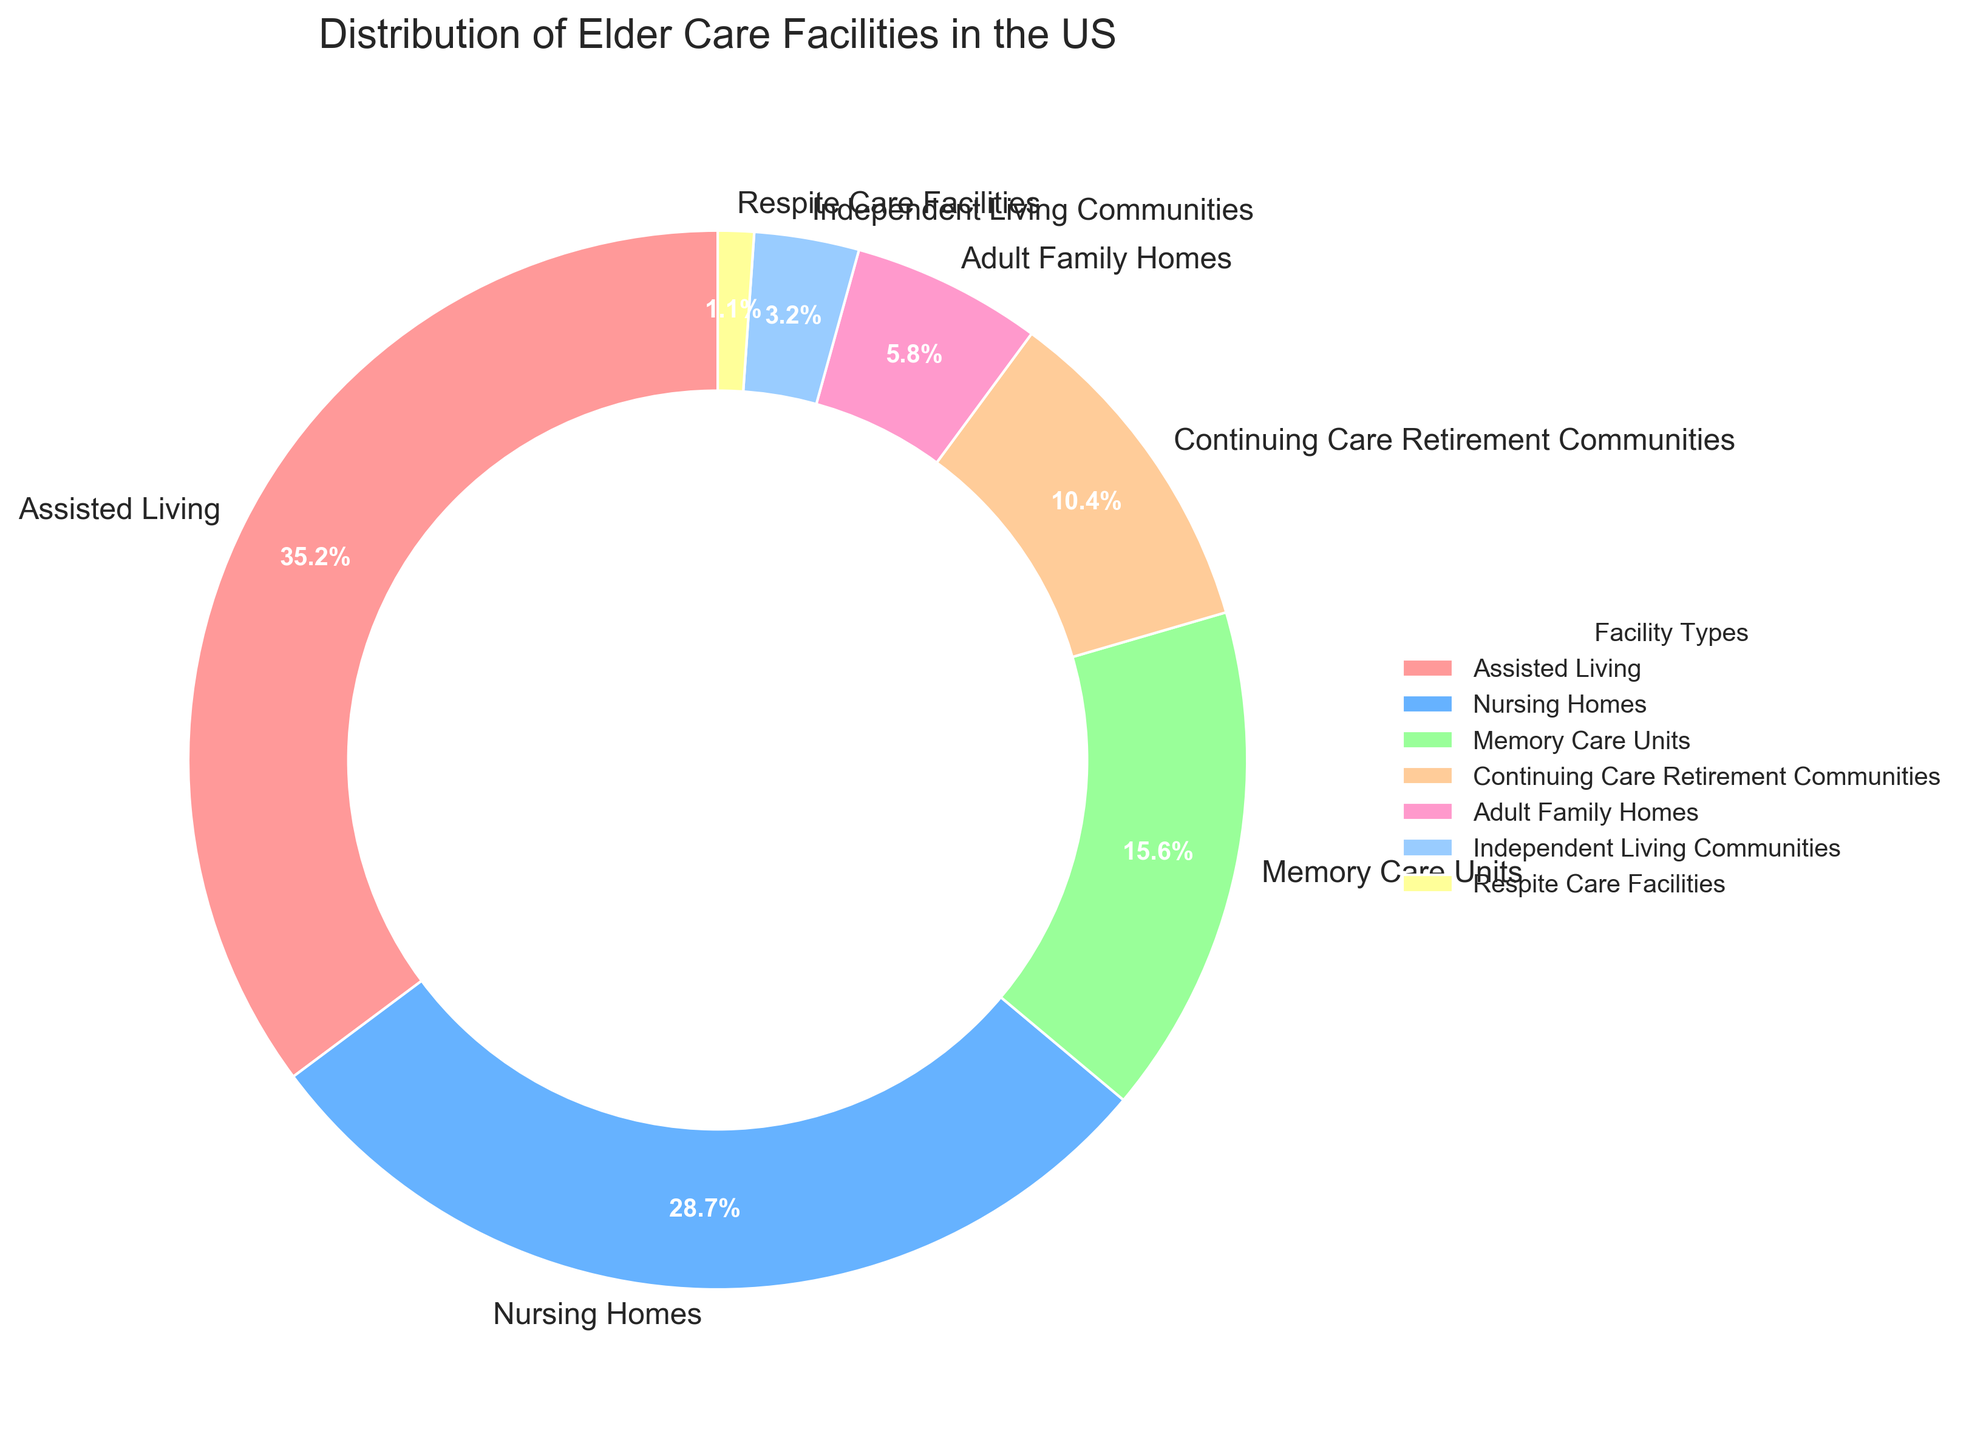What's the facility type with the largest percentage? The pie chart shows that Assisted Living has the largest segment with a percentage of 35.2%.
Answer: Assisted Living Which two facility types combined have more than 50% presence? Assisted Living at 35.2% and Nursing Homes at 28.7% combined have 63.9%, which is more than 50%.
Answer: Assisted Living and Nursing Homes What's the difference in percentage between Nursing Homes and Memory Care Units? Nursing Homes have 28.7% and Memory Care Units have 15.6%. The difference is 28.7% - 15.6% = 13.1%.
Answer: 13.1% What percentage do Adult Family Homes and Respite Care Facilities make up together? Adult Family Homes have 5.8% and Respite Care Facilities have 1.1%. Their combined percentage is 5.8% + 1.1% = 6.9%.
Answer: 6.9% How many facility types account for less than 10% of the distribution each? The facility types with less than 10% each are Adult Family Homes (5.8%), Independent Living Communities (3.2%), and Respite Care Facilities (1.1%). There are 3 such types.
Answer: 3 Is the percentage of Continuing Care Retirement Communities higher or lower than Memory Care Units? Continuing Care Retirement Communities have 10.4% and Memory Care Units have 15.6%, so Continuing Care Retirement Communities are lower.
Answer: Lower Which facility type is represented by the segment colored in blue? The blue segment corresponds to Nursing Homes with a 28.7% share.
Answer: Nursing Homes What is the combined percentage of the least common three facility types? The least common three facility types are Independent Living Communities (3.2%), Respite Care Facilities (1.1%), and Adult Family Homes (5.8%). Their combined percentage is 3.2% + 1.1% + 5.8% = 10.1%.
Answer: 10.1% If the percentage of Assisted Living increased by 4%, what would be its new percentage? The current percentage of Assisted Living is 35.2%. With a 4% increase, it would be 35.2% + 4% = 39.2%.
Answer: 39.2% Which facility type is closest to accounting for one-third of the distribution? One-third of the distribution is approximately 33.33%. Assisted Living is closest with 35.2%.
Answer: Assisted Living 